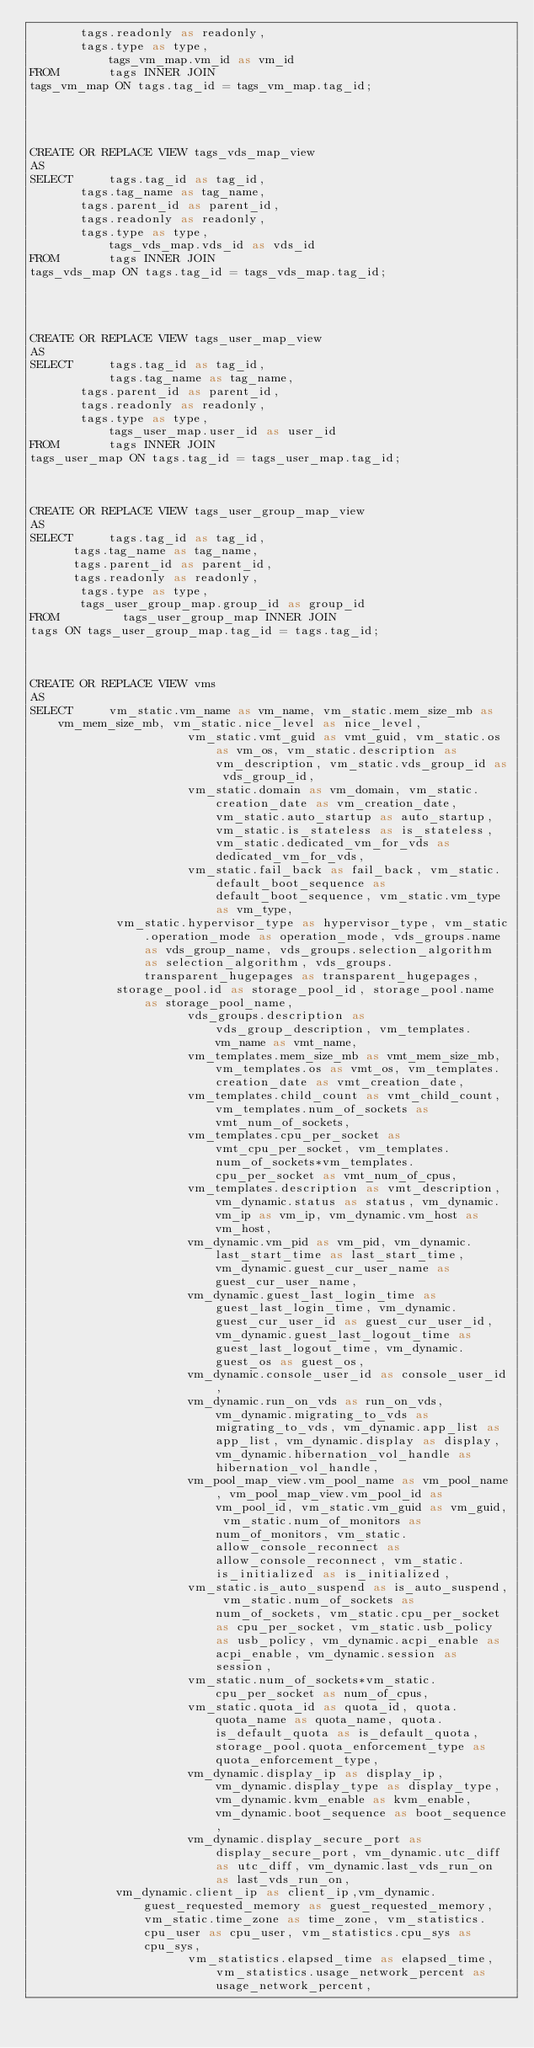Convert code to text. <code><loc_0><loc_0><loc_500><loc_500><_SQL_>		   tags.readonly as readonly,
		   tags.type as type,
           tags_vm_map.vm_id as vm_id
FROM       tags INNER JOIN
tags_vm_map ON tags.tag_id = tags_vm_map.tag_id;




CREATE OR REPLACE VIEW tags_vds_map_view
AS
SELECT     tags.tag_id as tag_id,
		   tags.tag_name as tag_name,
		   tags.parent_id as parent_id,
		   tags.readonly as readonly,
		   tags.type as type,
           tags_vds_map.vds_id as vds_id
FROM       tags INNER JOIN
tags_vds_map ON tags.tag_id = tags_vds_map.tag_id;




CREATE OR REPLACE VIEW tags_user_map_view
AS
SELECT     tags.tag_id as tag_id,
           tags.tag_name as tag_name,
		   tags.parent_id as parent_id,
		   tags.readonly as readonly,
		   tags.type as type,
           tags_user_map.user_id as user_id
FROM       tags INNER JOIN
tags_user_map ON tags.tag_id = tags_user_map.tag_id;



CREATE OR REPLACE VIEW tags_user_group_map_view
AS
SELECT     tags.tag_id as tag_id,
			tags.tag_name as tag_name,
			tags.parent_id as parent_id,
			tags.readonly as readonly,
		   tags.type as type,
			 tags_user_group_map.group_id as group_id
FROM         tags_user_group_map INNER JOIN
tags ON tags_user_group_map.tag_id = tags.tag_id;



CREATE OR REPLACE VIEW vms
AS
SELECT     vm_static.vm_name as vm_name, vm_static.mem_size_mb as vm_mem_size_mb, vm_static.nice_level as nice_level,
                      vm_static.vmt_guid as vmt_guid, vm_static.os as vm_os, vm_static.description as vm_description, vm_static.vds_group_id as vds_group_id,
                      vm_static.domain as vm_domain, vm_static.creation_date as vm_creation_date, vm_static.auto_startup as auto_startup, vm_static.is_stateless as is_stateless, vm_static.dedicated_vm_for_vds as dedicated_vm_for_vds,
                      vm_static.fail_back as fail_back, vm_static.default_boot_sequence as default_boot_sequence, vm_static.vm_type as vm_type,
					  vm_static.hypervisor_type as hypervisor_type, vm_static.operation_mode as operation_mode, vds_groups.name as vds_group_name, vds_groups.selection_algorithm as selection_algorithm, vds_groups.transparent_hugepages as transparent_hugepages,
					  storage_pool.id as storage_pool_id, storage_pool.name as storage_pool_name,
                      vds_groups.description as vds_group_description, vm_templates.vm_name as vmt_name,
                      vm_templates.mem_size_mb as vmt_mem_size_mb, vm_templates.os as vmt_os, vm_templates.creation_date as vmt_creation_date,
                      vm_templates.child_count as vmt_child_count, vm_templates.num_of_sockets as vmt_num_of_sockets,
                      vm_templates.cpu_per_socket as vmt_cpu_per_socket, vm_templates.num_of_sockets*vm_templates.cpu_per_socket as vmt_num_of_cpus,
                      vm_templates.description as vmt_description, vm_dynamic.status as status, vm_dynamic.vm_ip as vm_ip, vm_dynamic.vm_host as vm_host,
                      vm_dynamic.vm_pid as vm_pid, vm_dynamic.last_start_time as last_start_time, vm_dynamic.guest_cur_user_name as guest_cur_user_name,
                      vm_dynamic.guest_last_login_time as guest_last_login_time, vm_dynamic.guest_cur_user_id as guest_cur_user_id, vm_dynamic.guest_last_logout_time as guest_last_logout_time, vm_dynamic.guest_os as guest_os,
                      vm_dynamic.console_user_id as console_user_id,
                      vm_dynamic.run_on_vds as run_on_vds, vm_dynamic.migrating_to_vds as migrating_to_vds, vm_dynamic.app_list as app_list, vm_dynamic.display as display, vm_dynamic.hibernation_vol_handle as hibernation_vol_handle,
                      vm_pool_map_view.vm_pool_name as vm_pool_name, vm_pool_map_view.vm_pool_id as vm_pool_id, vm_static.vm_guid as vm_guid, vm_static.num_of_monitors as num_of_monitors, vm_static.allow_console_reconnect as allow_console_reconnect, vm_static.is_initialized as is_initialized,
                      vm_static.is_auto_suspend as is_auto_suspend, vm_static.num_of_sockets as num_of_sockets, vm_static.cpu_per_socket as cpu_per_socket, vm_static.usb_policy as usb_policy, vm_dynamic.acpi_enable as acpi_enable, vm_dynamic.session as session,
                      vm_static.num_of_sockets*vm_static.cpu_per_socket as num_of_cpus,
                      vm_static.quota_id as quota_id, quota.quota_name as quota_name, quota.is_default_quota as is_default_quota, storage_pool.quota_enforcement_type as quota_enforcement_type,
                      vm_dynamic.display_ip as display_ip, vm_dynamic.display_type as display_type, vm_dynamic.kvm_enable as kvm_enable, vm_dynamic.boot_sequence as boot_sequence,
                      vm_dynamic.display_secure_port as display_secure_port, vm_dynamic.utc_diff as utc_diff, vm_dynamic.last_vds_run_on as last_vds_run_on,
					  vm_dynamic.client_ip as client_ip,vm_dynamic.guest_requested_memory as guest_requested_memory, vm_static.time_zone as time_zone, vm_statistics.cpu_user as cpu_user, vm_statistics.cpu_sys as cpu_sys,
                      vm_statistics.elapsed_time as elapsed_time, vm_statistics.usage_network_percent as usage_network_percent,</code> 